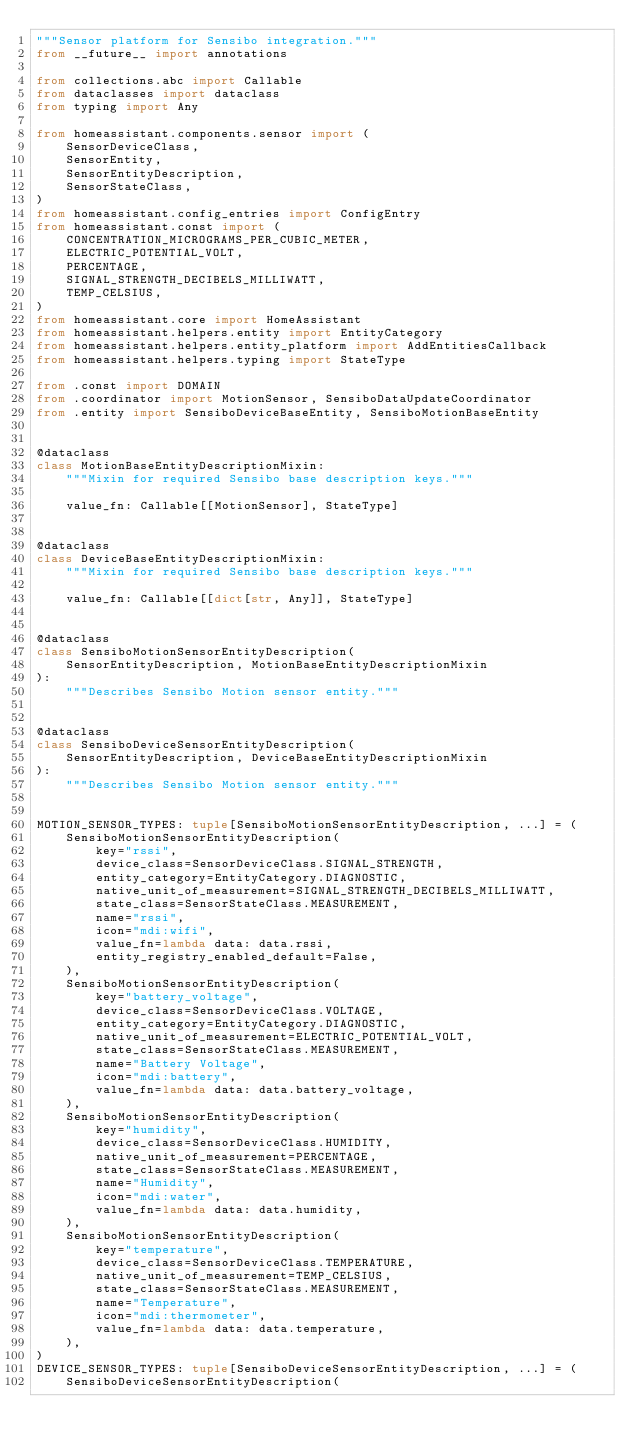Convert code to text. <code><loc_0><loc_0><loc_500><loc_500><_Python_>"""Sensor platform for Sensibo integration."""
from __future__ import annotations

from collections.abc import Callable
from dataclasses import dataclass
from typing import Any

from homeassistant.components.sensor import (
    SensorDeviceClass,
    SensorEntity,
    SensorEntityDescription,
    SensorStateClass,
)
from homeassistant.config_entries import ConfigEntry
from homeassistant.const import (
    CONCENTRATION_MICROGRAMS_PER_CUBIC_METER,
    ELECTRIC_POTENTIAL_VOLT,
    PERCENTAGE,
    SIGNAL_STRENGTH_DECIBELS_MILLIWATT,
    TEMP_CELSIUS,
)
from homeassistant.core import HomeAssistant
from homeassistant.helpers.entity import EntityCategory
from homeassistant.helpers.entity_platform import AddEntitiesCallback
from homeassistant.helpers.typing import StateType

from .const import DOMAIN
from .coordinator import MotionSensor, SensiboDataUpdateCoordinator
from .entity import SensiboDeviceBaseEntity, SensiboMotionBaseEntity


@dataclass
class MotionBaseEntityDescriptionMixin:
    """Mixin for required Sensibo base description keys."""

    value_fn: Callable[[MotionSensor], StateType]


@dataclass
class DeviceBaseEntityDescriptionMixin:
    """Mixin for required Sensibo base description keys."""

    value_fn: Callable[[dict[str, Any]], StateType]


@dataclass
class SensiboMotionSensorEntityDescription(
    SensorEntityDescription, MotionBaseEntityDescriptionMixin
):
    """Describes Sensibo Motion sensor entity."""


@dataclass
class SensiboDeviceSensorEntityDescription(
    SensorEntityDescription, DeviceBaseEntityDescriptionMixin
):
    """Describes Sensibo Motion sensor entity."""


MOTION_SENSOR_TYPES: tuple[SensiboMotionSensorEntityDescription, ...] = (
    SensiboMotionSensorEntityDescription(
        key="rssi",
        device_class=SensorDeviceClass.SIGNAL_STRENGTH,
        entity_category=EntityCategory.DIAGNOSTIC,
        native_unit_of_measurement=SIGNAL_STRENGTH_DECIBELS_MILLIWATT,
        state_class=SensorStateClass.MEASUREMENT,
        name="rssi",
        icon="mdi:wifi",
        value_fn=lambda data: data.rssi,
        entity_registry_enabled_default=False,
    ),
    SensiboMotionSensorEntityDescription(
        key="battery_voltage",
        device_class=SensorDeviceClass.VOLTAGE,
        entity_category=EntityCategory.DIAGNOSTIC,
        native_unit_of_measurement=ELECTRIC_POTENTIAL_VOLT,
        state_class=SensorStateClass.MEASUREMENT,
        name="Battery Voltage",
        icon="mdi:battery",
        value_fn=lambda data: data.battery_voltage,
    ),
    SensiboMotionSensorEntityDescription(
        key="humidity",
        device_class=SensorDeviceClass.HUMIDITY,
        native_unit_of_measurement=PERCENTAGE,
        state_class=SensorStateClass.MEASUREMENT,
        name="Humidity",
        icon="mdi:water",
        value_fn=lambda data: data.humidity,
    ),
    SensiboMotionSensorEntityDescription(
        key="temperature",
        device_class=SensorDeviceClass.TEMPERATURE,
        native_unit_of_measurement=TEMP_CELSIUS,
        state_class=SensorStateClass.MEASUREMENT,
        name="Temperature",
        icon="mdi:thermometer",
        value_fn=lambda data: data.temperature,
    ),
)
DEVICE_SENSOR_TYPES: tuple[SensiboDeviceSensorEntityDescription, ...] = (
    SensiboDeviceSensorEntityDescription(</code> 